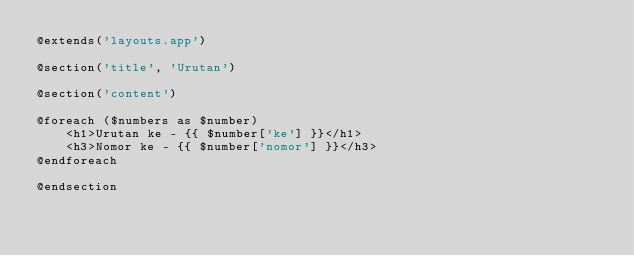Convert code to text. <code><loc_0><loc_0><loc_500><loc_500><_PHP_>@extends('layouts.app')

@section('title', 'Urutan')

@section('content')

@foreach ($numbers as $number)
    <h1>Urutan ke - {{ $number['ke'] }}</h1>
    <h3>Nomor ke - {{ $number['nomor'] }}</h3>
@endforeach

@endsection</code> 